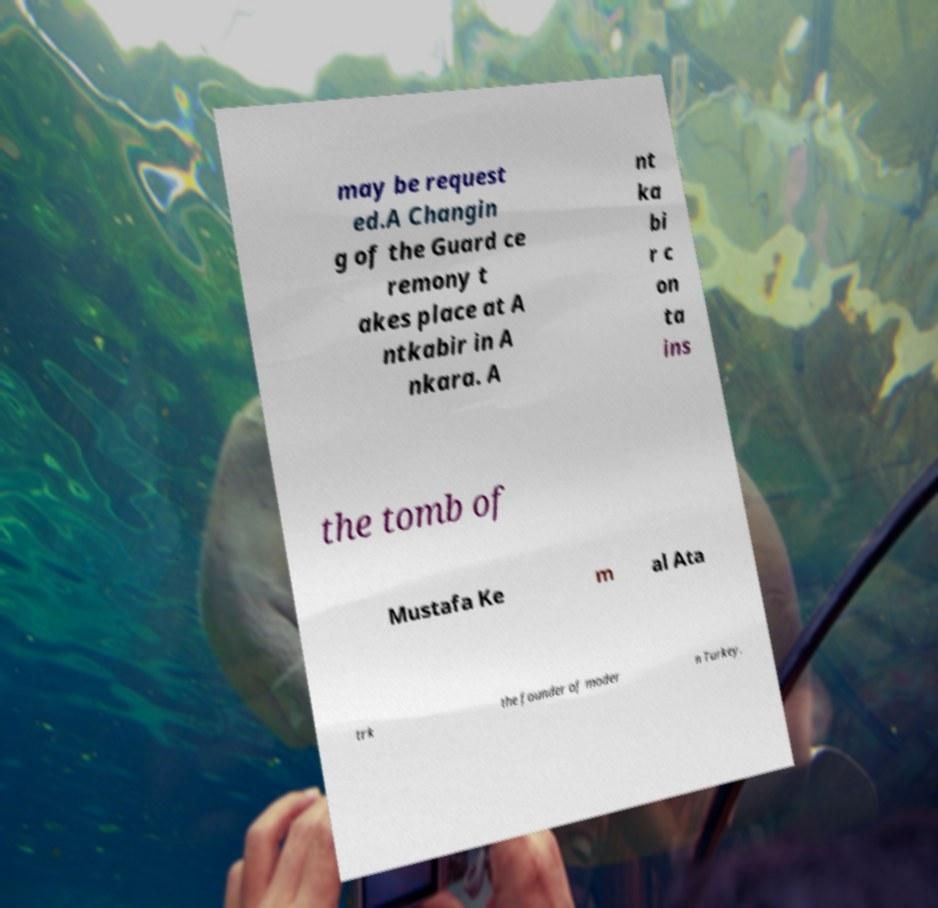There's text embedded in this image that I need extracted. Can you transcribe it verbatim? may be request ed.A Changin g of the Guard ce remony t akes place at A ntkabir in A nkara. A nt ka bi r c on ta ins the tomb of Mustafa Ke m al Ata trk the founder of moder n Turkey. 